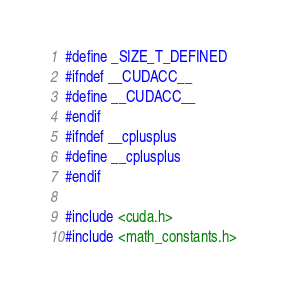Convert code to text. <code><loc_0><loc_0><loc_500><loc_500><_Cuda_>#define _SIZE_T_DEFINED 
#ifndef __CUDACC__ 
#define __CUDACC__ 
#endif 
#ifndef __cplusplus 
#define __cplusplus 
#endif

#include <cuda.h> 
#include <math_constants.h> </code> 